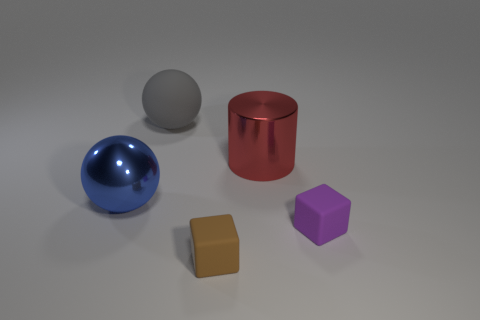Add 1 red shiny things. How many objects exist? 6 Subtract all balls. How many objects are left? 3 Subtract 0 purple balls. How many objects are left? 5 Subtract all large things. Subtract all large matte things. How many objects are left? 1 Add 4 metallic cylinders. How many metallic cylinders are left? 5 Add 3 big blue cylinders. How many big blue cylinders exist? 3 